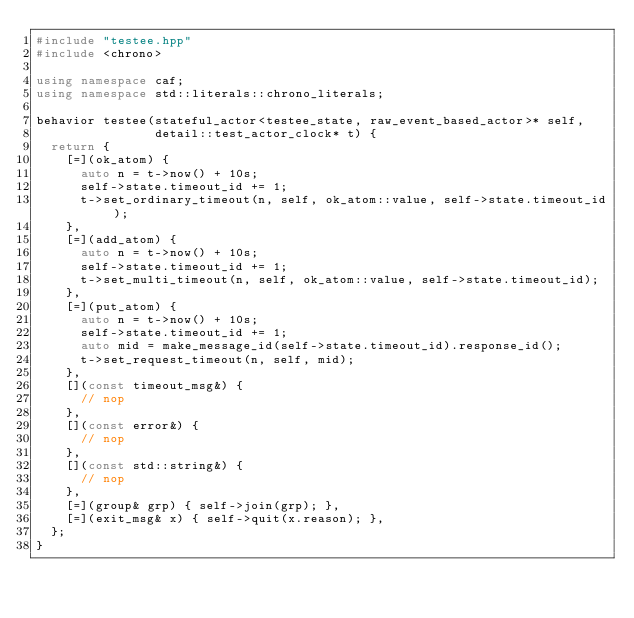<code> <loc_0><loc_0><loc_500><loc_500><_C++_>#include "testee.hpp"
#include <chrono>

using namespace caf;
using namespace std::literals::chrono_literals;

behavior testee(stateful_actor<testee_state, raw_event_based_actor>* self,
                detail::test_actor_clock* t) {
  return {
    [=](ok_atom) {
      auto n = t->now() + 10s;
      self->state.timeout_id += 1;
      t->set_ordinary_timeout(n, self, ok_atom::value, self->state.timeout_id);
    },
    [=](add_atom) {
      auto n = t->now() + 10s;
      self->state.timeout_id += 1;
      t->set_multi_timeout(n, self, ok_atom::value, self->state.timeout_id);
    },
    [=](put_atom) {
      auto n = t->now() + 10s;
      self->state.timeout_id += 1;
      auto mid = make_message_id(self->state.timeout_id).response_id();
      t->set_request_timeout(n, self, mid);
    },
    [](const timeout_msg&) {
      // nop
    },
    [](const error&) {
      // nop
    },
    [](const std::string&) {
      // nop
    },
    [=](group& grp) { self->join(grp); },
    [=](exit_msg& x) { self->quit(x.reason); },
  };
}
</code> 